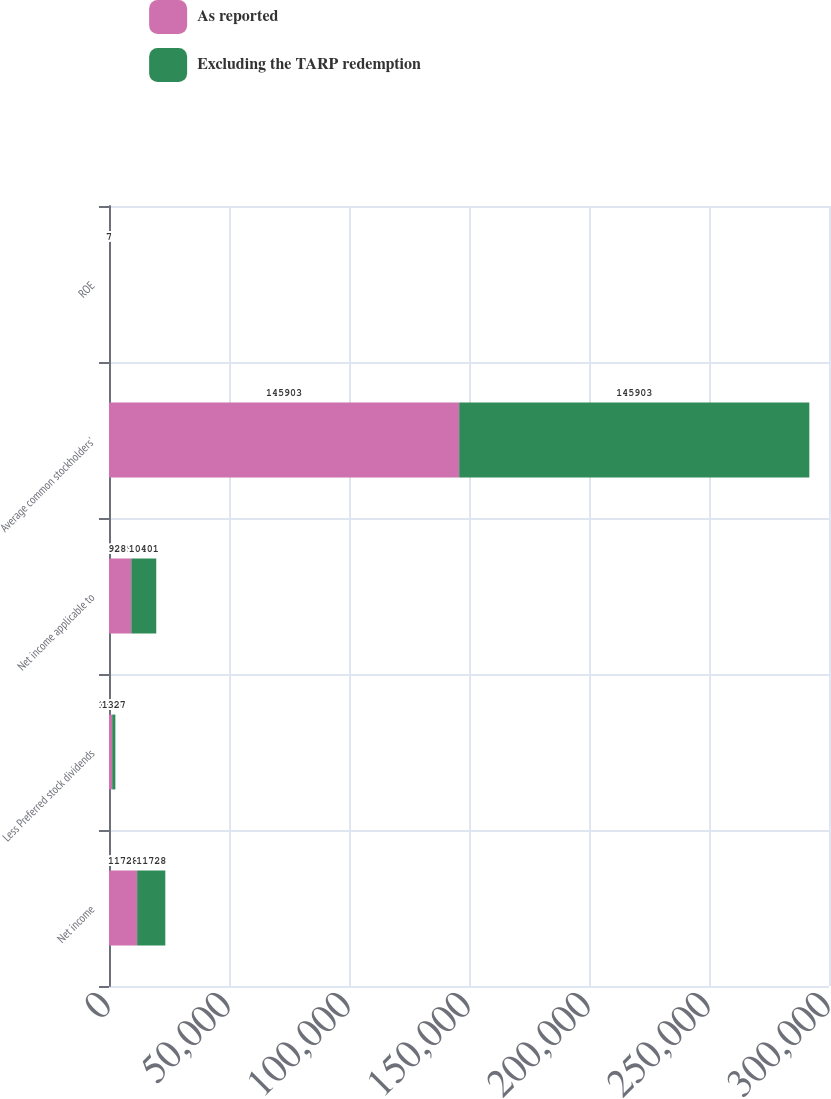Convert chart to OTSL. <chart><loc_0><loc_0><loc_500><loc_500><stacked_bar_chart><ecel><fcel>Net income<fcel>Less Preferred stock dividends<fcel>Net income applicable to<fcel>Average common stockholders'<fcel>ROE<nl><fcel>As reported<fcel>11728<fcel>1327<fcel>9289<fcel>145903<fcel>6<nl><fcel>Excluding the TARP redemption<fcel>11728<fcel>1327<fcel>10401<fcel>145903<fcel>7<nl></chart> 